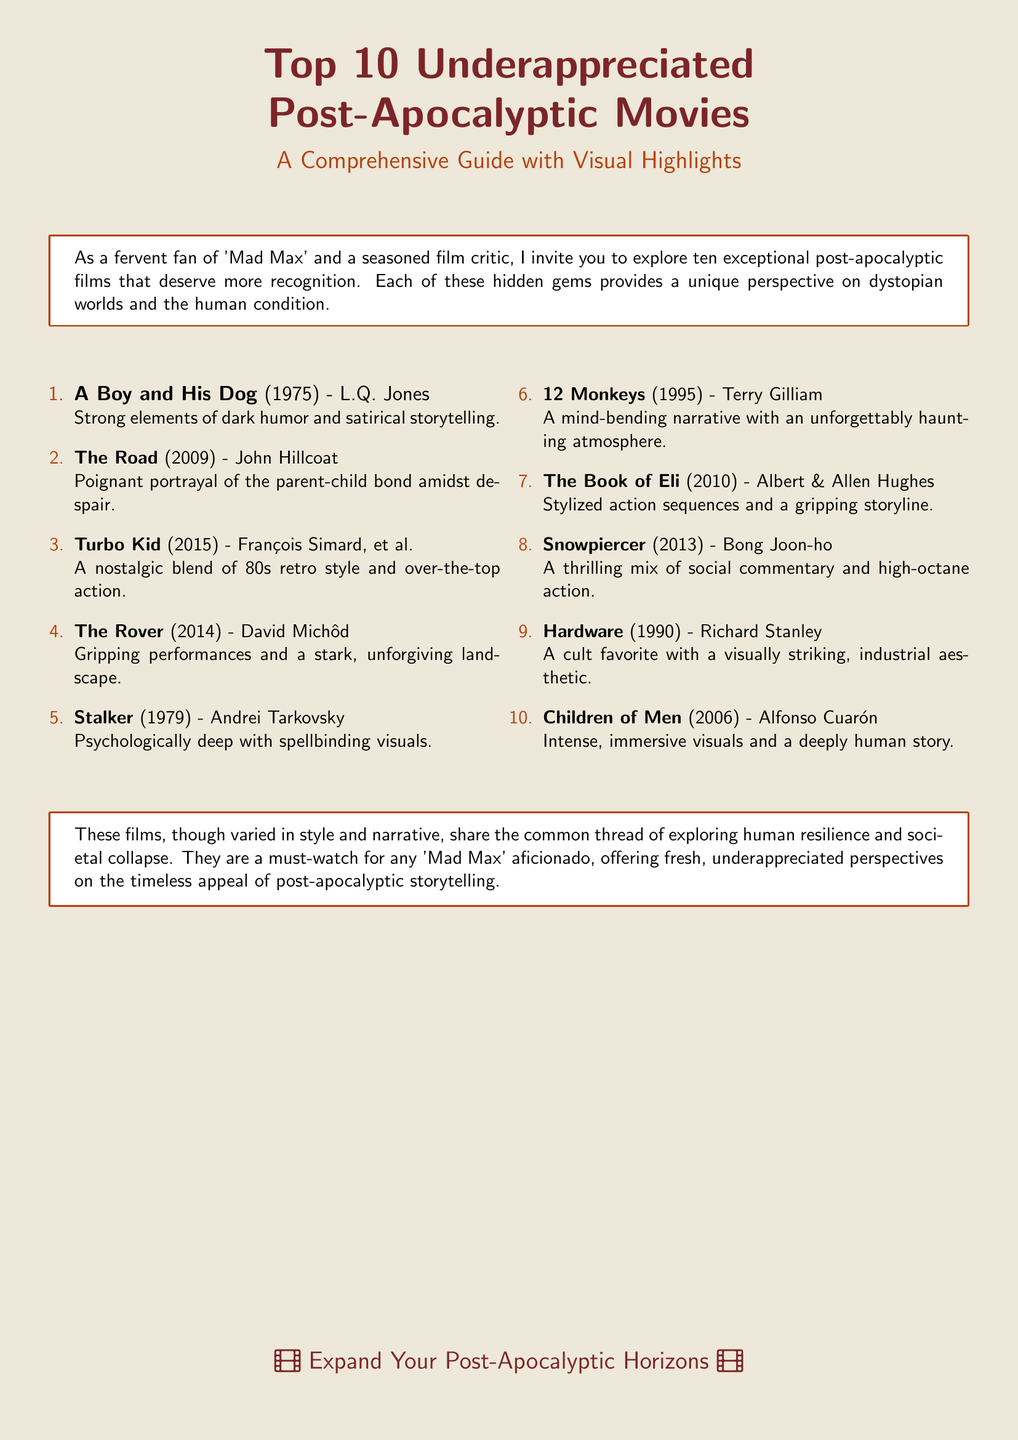what is the title of the guide? The title of the guide is prominently displayed at the top of the document.
Answer: Top 10 Underappreciated Post-Apocalyptic Movies who directed ‘The Road’? The document lists the director of 'The Road' alongside the film title in the enumeration.
Answer: John Hillcoat which movie features a nostalgic blend of 80s retro style? This information is indicated under the movie description in the list.
Answer: Turbo Kid how many films are listed in the document? The document enumerates the films, making it clear how many are included.
Answer: 10 which movie is described as having "spellbinding visuals"? This description is given directly under the film title in the enumeration.
Answer: Stalker who directed ‘Children of Men’? The director of 'Children of Men' is acknowledged in the document.
Answer: Alfonso Cuarón what common theme do these films explore? The document concludes with a statement summarizing the overarching theme of the films listed.
Answer: Human resilience what year was ‘Hardware’ released? The release year of 'Hardware' is specified next to the title in the list.
Answer: 1990 which film is considered a cult favorite? The document labels one of the films specifically as a cult favorite within its description.
Answer: Hardware 